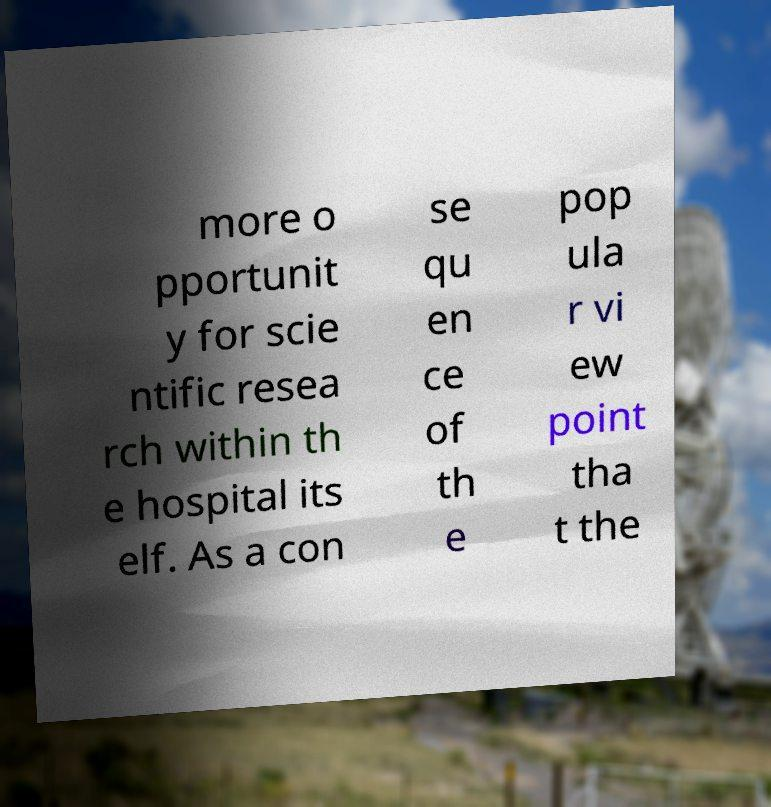There's text embedded in this image that I need extracted. Can you transcribe it verbatim? more o pportunit y for scie ntific resea rch within th e hospital its elf. As a con se qu en ce of th e pop ula r vi ew point tha t the 